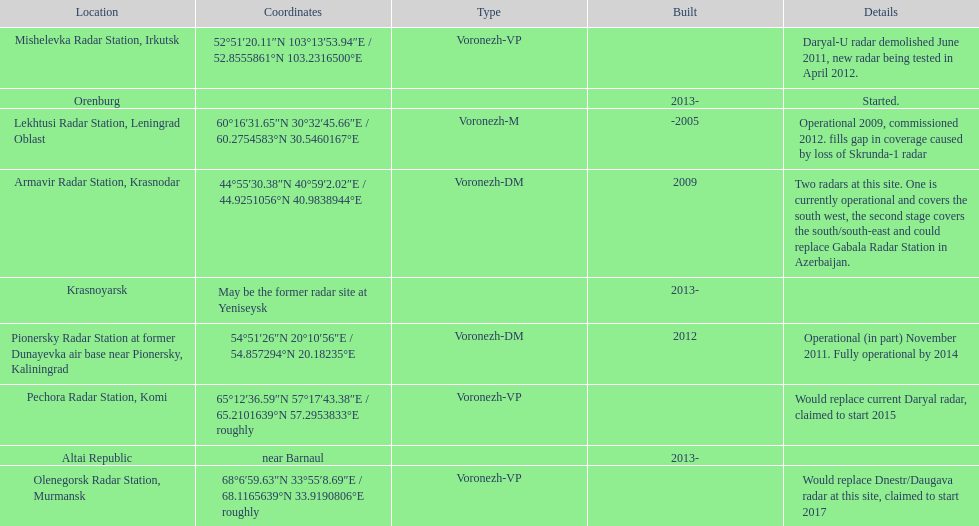What year built is at the top? -2005. 